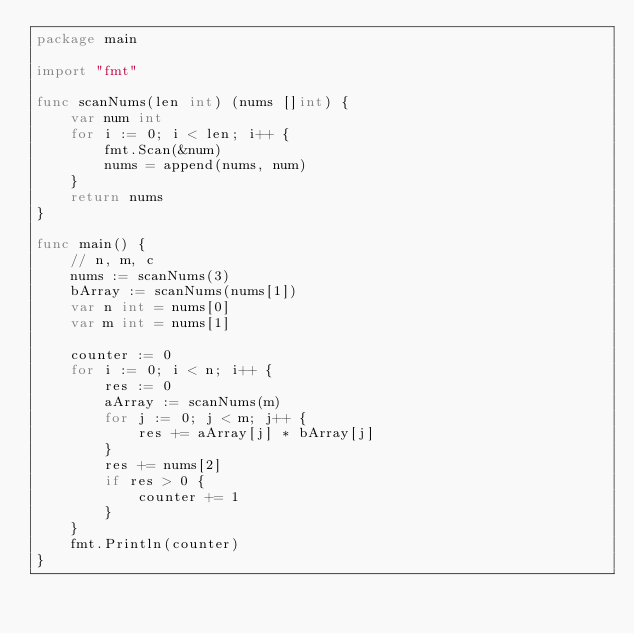Convert code to text. <code><loc_0><loc_0><loc_500><loc_500><_Go_>package main

import "fmt"

func scanNums(len int) (nums []int) {
	var num int
	for i := 0; i < len; i++ {
		fmt.Scan(&num)
		nums = append(nums, num)
	}
	return nums
}

func main() {
	// n, m, c
	nums := scanNums(3)
	bArray := scanNums(nums[1])
	var n int = nums[0]
	var m int = nums[1]

	counter := 0
	for i := 0; i < n; i++ {
		res := 0
		aArray := scanNums(m)
		for j := 0; j < m; j++ {
			res += aArray[j] * bArray[j]
		}
		res += nums[2]
		if res > 0 {
			counter += 1
		}
	}
	fmt.Println(counter)
}
</code> 